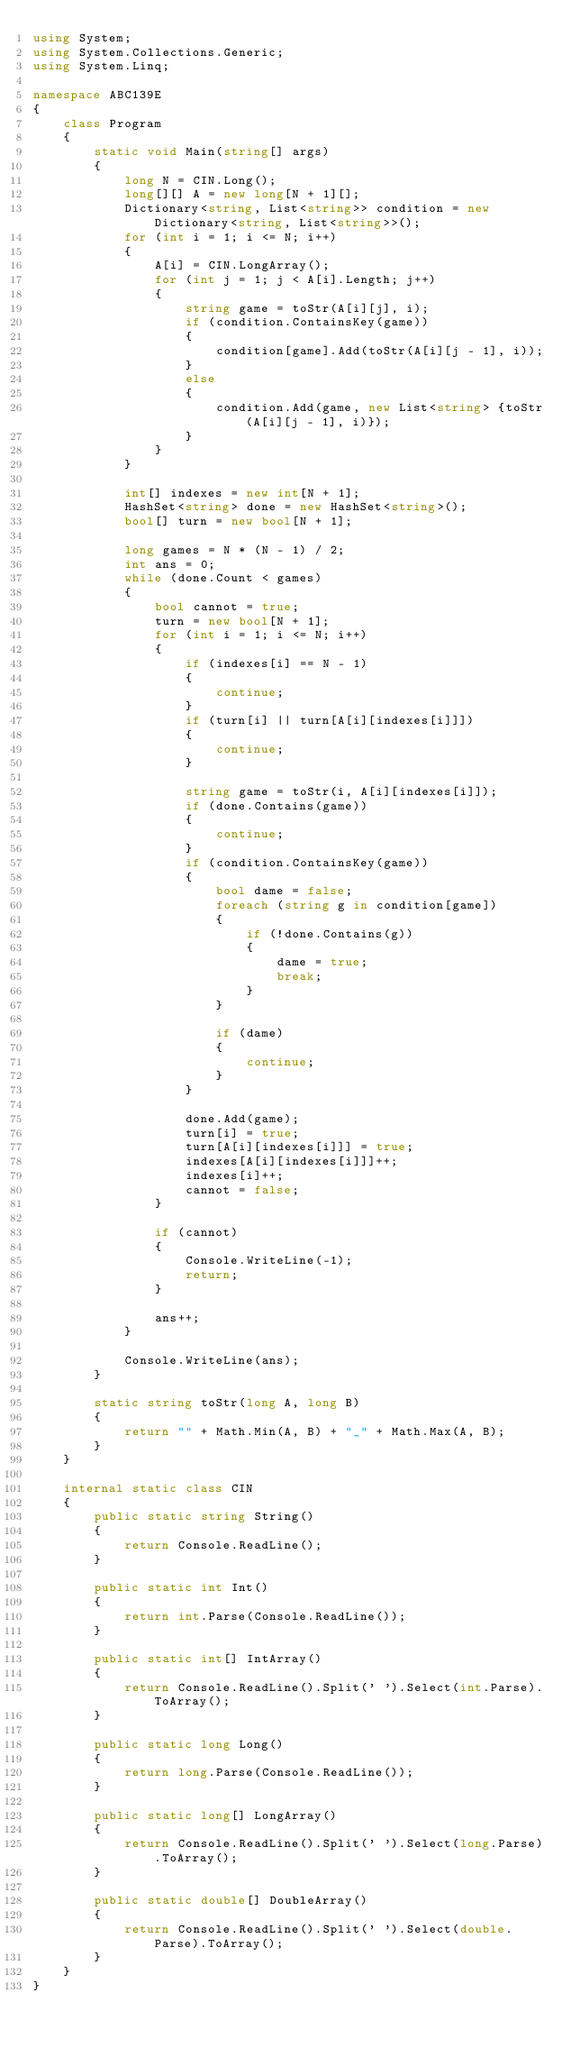Convert code to text. <code><loc_0><loc_0><loc_500><loc_500><_C#_>using System;
using System.Collections.Generic;
using System.Linq;

namespace ABC139E
{
    class Program
    {
        static void Main(string[] args)
        {
            long N = CIN.Long();
            long[][] A = new long[N + 1][];
            Dictionary<string, List<string>> condition = new Dictionary<string, List<string>>();
            for (int i = 1; i <= N; i++)
            {
                A[i] = CIN.LongArray();
                for (int j = 1; j < A[i].Length; j++)
                {
                    string game = toStr(A[i][j], i);
                    if (condition.ContainsKey(game))
                    {
                        condition[game].Add(toStr(A[i][j - 1], i));
                    }
                    else
                    {
                        condition.Add(game, new List<string> {toStr(A[i][j - 1], i)});
                    }
                }
            }

            int[] indexes = new int[N + 1];
            HashSet<string> done = new HashSet<string>();
            bool[] turn = new bool[N + 1];

            long games = N * (N - 1) / 2;
            int ans = 0;
            while (done.Count < games)
            {
                bool cannot = true;
                turn = new bool[N + 1];
                for (int i = 1; i <= N; i++)
                {
                    if (indexes[i] == N - 1)
                    {
                        continue;
                    }
                    if (turn[i] || turn[A[i][indexes[i]]])
                    {
                        continue;
                    }

                    string game = toStr(i, A[i][indexes[i]]);
                    if (done.Contains(game))
                    {
                        continue;
                    }
                    if (condition.ContainsKey(game))
                    {
                        bool dame = false;
                        foreach (string g in condition[game])
                        {
                            if (!done.Contains(g))
                            {
                                dame = true;
                                break;
                            }
                        }

                        if (dame)
                        {
                            continue;
                        }
                    }

                    done.Add(game);
                    turn[i] = true;
                    turn[A[i][indexes[i]]] = true;
                    indexes[A[i][indexes[i]]]++;
                    indexes[i]++;
                    cannot = false;
                }

                if (cannot)
                {
                    Console.WriteLine(-1);
                    return;
                }

                ans++;
            }

            Console.WriteLine(ans);
        }

        static string toStr(long A, long B)
        {
            return "" + Math.Min(A, B) + "_" + Math.Max(A, B);
        }
    }

    internal static class CIN
    {
        public static string String()
        {
            return Console.ReadLine();
        }

        public static int Int()
        {
            return int.Parse(Console.ReadLine());
        }

        public static int[] IntArray()
        {
            return Console.ReadLine().Split(' ').Select(int.Parse).ToArray();
        }

        public static long Long()
        {
            return long.Parse(Console.ReadLine());
        }

        public static long[] LongArray()
        {
            return Console.ReadLine().Split(' ').Select(long.Parse).ToArray();
        }

        public static double[] DoubleArray()
        {
            return Console.ReadLine().Split(' ').Select(double.Parse).ToArray();
        }
    }
}</code> 